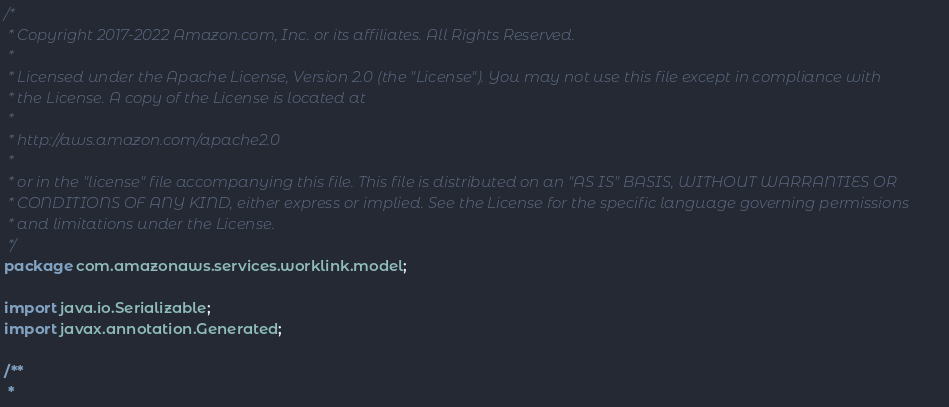<code> <loc_0><loc_0><loc_500><loc_500><_Java_>/*
 * Copyright 2017-2022 Amazon.com, Inc. or its affiliates. All Rights Reserved.
 * 
 * Licensed under the Apache License, Version 2.0 (the "License"). You may not use this file except in compliance with
 * the License. A copy of the License is located at
 * 
 * http://aws.amazon.com/apache2.0
 * 
 * or in the "license" file accompanying this file. This file is distributed on an "AS IS" BASIS, WITHOUT WARRANTIES OR
 * CONDITIONS OF ANY KIND, either express or implied. See the License for the specific language governing permissions
 * and limitations under the License.
 */
package com.amazonaws.services.worklink.model;

import java.io.Serializable;
import javax.annotation.Generated;

/**
 * </code> 